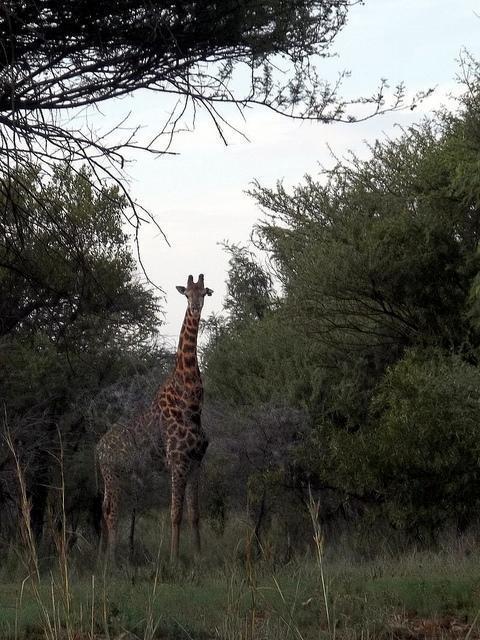How many animals?
Give a very brief answer. 1. How many animals are standing in the forest?
Give a very brief answer. 1. How many people are wearing a birthday hat?
Give a very brief answer. 0. 